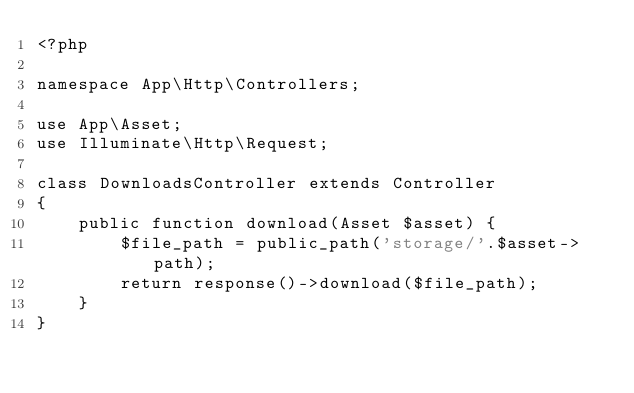<code> <loc_0><loc_0><loc_500><loc_500><_PHP_><?php

namespace App\Http\Controllers;

use App\Asset;
use Illuminate\Http\Request;

class DownloadsController extends Controller
{
    public function download(Asset $asset) {
        $file_path = public_path('storage/'.$asset->path);
        return response()->download($file_path);
    }
}
</code> 